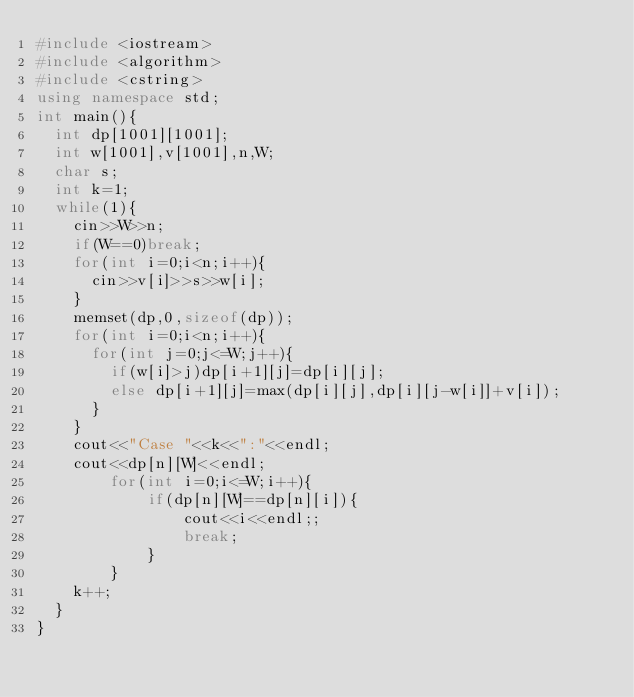<code> <loc_0><loc_0><loc_500><loc_500><_C++_>#include <iostream>
#include <algorithm>
#include <cstring>
using namespace std;
int main(){
	int dp[1001][1001];
	int w[1001],v[1001],n,W;
	char s;
	int k=1;
	while(1){
		cin>>W>>n;
		if(W==0)break;
		for(int i=0;i<n;i++){
			cin>>v[i]>>s>>w[i];
		}
		memset(dp,0,sizeof(dp));
		for(int i=0;i<n;i++){
			for(int j=0;j<=W;j++){
				if(w[i]>j)dp[i+1][j]=dp[i][j];
				else dp[i+1][j]=max(dp[i][j],dp[i][j-w[i]]+v[i]);
			}
		}
		cout<<"Case "<<k<<":"<<endl;
		cout<<dp[n][W]<<endl;
        for(int i=0;i<=W;i++){
            if(dp[n][W]==dp[n][i]){
                cout<<i<<endl;;
                break;
            }
        }
		k++;
	}
}</code> 